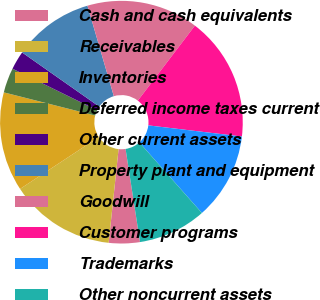<chart> <loc_0><loc_0><loc_500><loc_500><pie_chart><fcel>Cash and cash equivalents<fcel>Receivables<fcel>Inventories<fcel>Deferred income taxes current<fcel>Other current assets<fcel>Property plant and equipment<fcel>Goodwill<fcel>Customer programs<fcel>Trademarks<fcel>Other noncurrent assets<nl><fcel>4.13%<fcel>14.05%<fcel>13.22%<fcel>3.31%<fcel>2.48%<fcel>10.74%<fcel>14.87%<fcel>16.53%<fcel>11.57%<fcel>9.09%<nl></chart> 